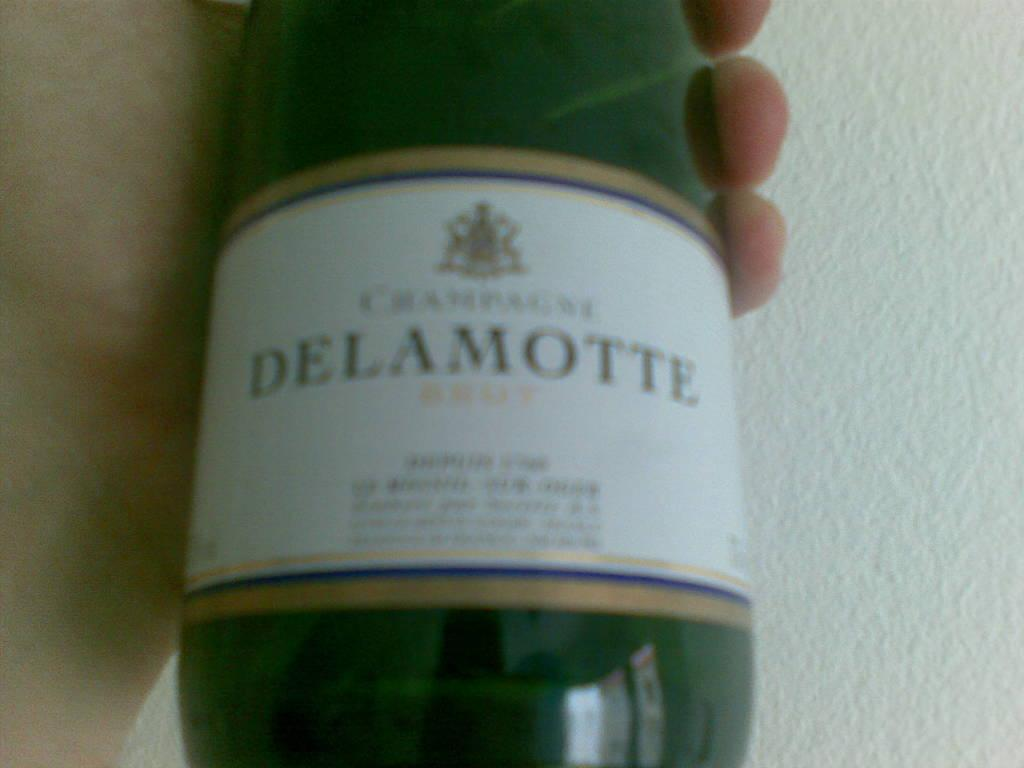<image>
Write a terse but informative summary of the picture. Someone holds a bottle of Delamotte in their hand. 